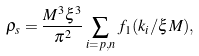Convert formula to latex. <formula><loc_0><loc_0><loc_500><loc_500>\rho _ { s } = \frac { M ^ { 3 } \xi ^ { 3 } } { \pi ^ { 2 } } \sum _ { i = p , n } f _ { 1 } ( k _ { i } / \xi M ) ,</formula> 